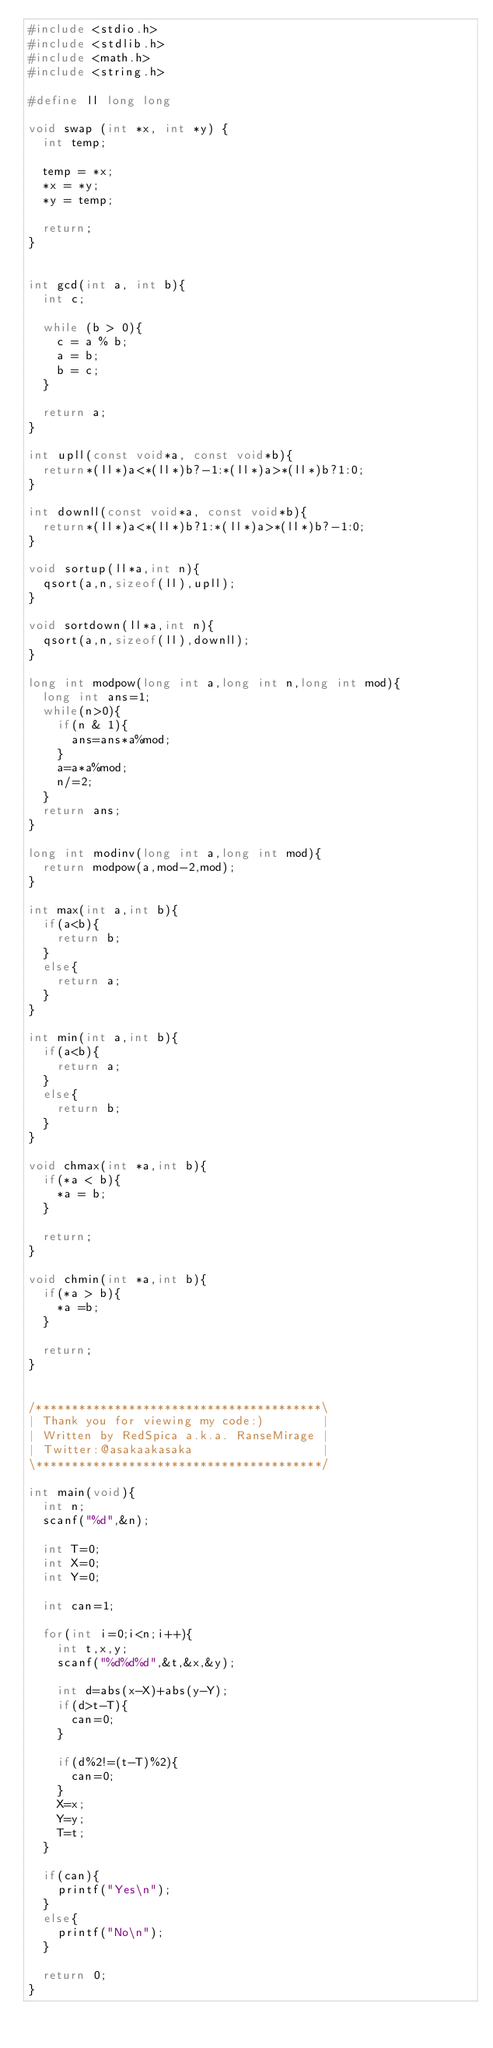<code> <loc_0><loc_0><loc_500><loc_500><_C_>#include <stdio.h>
#include <stdlib.h>
#include <math.h>
#include <string.h>

#define ll long long

void swap (int *x, int *y) {
  int temp;

  temp = *x;
  *x = *y;
  *y = temp;

  return;
}


int gcd(int a, int b){
  int c;

  while (b > 0){
    c = a % b;
    a = b;
    b = c;
  }

  return a;
}

int upll(const void*a, const void*b){
  return*(ll*)a<*(ll*)b?-1:*(ll*)a>*(ll*)b?1:0;
}

int downll(const void*a, const void*b){
  return*(ll*)a<*(ll*)b?1:*(ll*)a>*(ll*)b?-1:0;
}

void sortup(ll*a,int n){
  qsort(a,n,sizeof(ll),upll);
}

void sortdown(ll*a,int n){
  qsort(a,n,sizeof(ll),downll);
}

long int modpow(long int a,long int n,long int mod){
  long int ans=1;
  while(n>0){
    if(n & 1){
      ans=ans*a%mod;
    }
    a=a*a%mod;
    n/=2;
  }
  return ans;
}

long int modinv(long int a,long int mod){
  return modpow(a,mod-2,mod);
}

int max(int a,int b){
  if(a<b){
    return b;
  }
  else{
    return a;
  }
}

int min(int a,int b){
  if(a<b){
    return a;
  }
  else{
    return b;
  }
}

void chmax(int *a,int b){
  if(*a < b){
    *a = b;
  }

  return;
}

void chmin(int *a,int b){
  if(*a > b){
    *a =b;
  }

  return;
}


/****************************************\
| Thank you for viewing my code:)        |
| Written by RedSpica a.k.a. RanseMirage |
| Twitter:@asakaakasaka                  | 
\****************************************/

int main(void){
  int n;
  scanf("%d",&n);
 
  int T=0;
  int X=0;
  int Y=0;
 
  int can=1;
 
  for(int i=0;i<n;i++){
    int t,x,y;
    scanf("%d%d%d",&t,&x,&y);
 
    int d=abs(x-X)+abs(y-Y);
    if(d>t-T){
      can=0;
    }
 
    if(d%2!=(t-T)%2){
      can=0;
    }
    X=x;
    Y=y;
    T=t;
  }
 
  if(can){
    printf("Yes\n");
  }
  else{
    printf("No\n");
  }

  return 0;
}</code> 